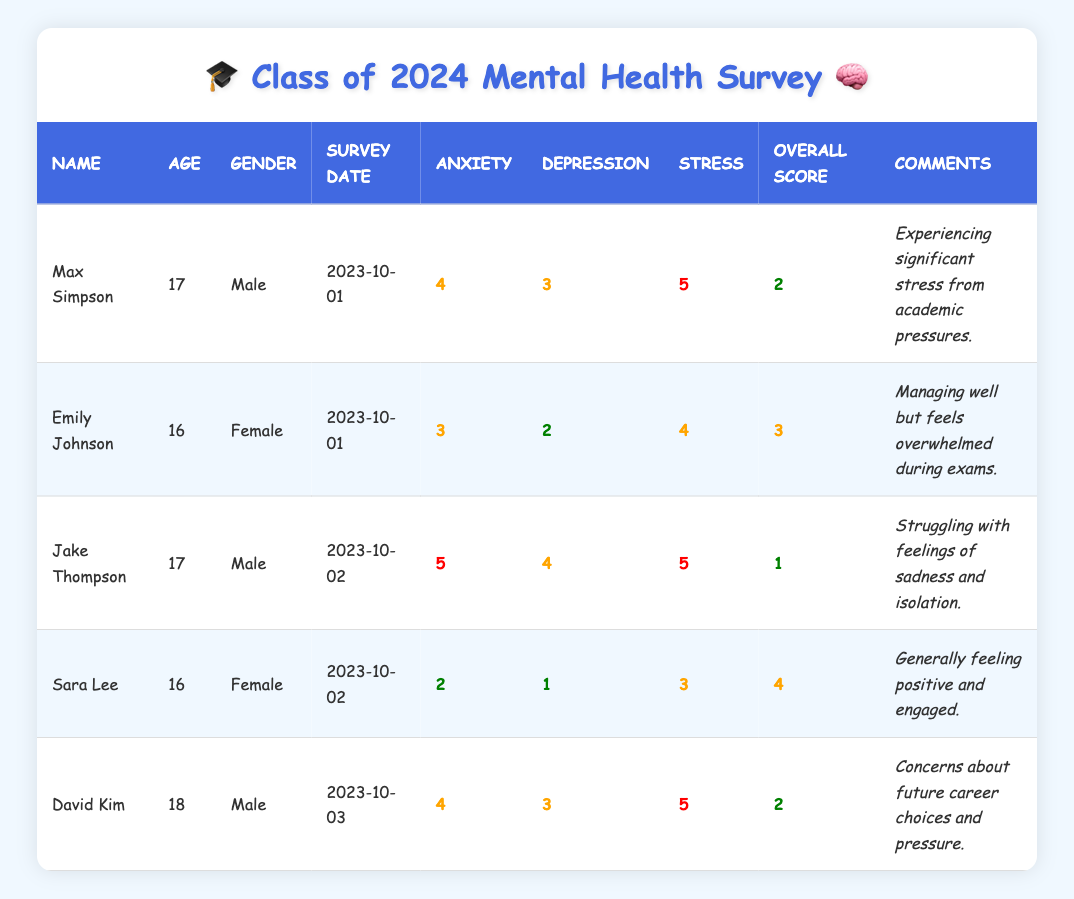What's the anxiety level reported by Max Simpson? The table shows that Max Simpson's anxiety level is listed under the "Anxiety" column, which has a value of 4.
Answer: 4 What is the overall mental health score of Sara Lee? In the table, we can find Sara Lee's overall mental health score in the "Overall Score" column, which is marked as 4.
Answer: 4 Who reported the highest stress level among the students? By looking at the "Stress" column, we can see that Jake Thompson has a stress level of 5, which is the highest compared to others.
Answer: Jake Thompson Is Emily Johnson's depression level higher than that of Max Simpson? We compare the depression levels in the "Depression" column: Emily Johnson has 2 and Max Simpson has 3. Since 2 is not greater than 3, the statement is false.
Answer: No What is the average anxiety level of all students surveyed? To find the average anxiety level, we add the anxiety levels: (4 + 3 + 5 + 2 + 4) = 18, and divide by 5 (the number of students). Thus, the average anxiety level is 18/5 = 3.6.
Answer: 3.6 How many students reported an overall mental health score of 2 or lower? Checking the "Overall Score" column, only Max Simpson and Jake Thompson reported scores of 2 or lower (Max with 2 and Jake with 1). Therefore, there are 2 students with such scores.
Answer: 2 Which student has the least concern about their mental health and how do we know? Sara Lee, who reported an overall mental health score of 4 and commented about feeling positive and engaged, has the least concern about her mental health. This is evident in her high score and positive comment.
Answer: Sara Lee What can we infer about the relationship between stress levels and overall mental health scores based on the table? By observing the data, there appears to be a trend where higher stress levels correlate with lower overall scores; for example, Jake Thompson has the highest stress level of 5 and the lowest overall score of 1, suggesting a negative relationship.
Answer: Higher stress levels correlate with lower overall scores Is there a student who feels overwhelmed during exams? Emily Johnson mentions feeling overwhelmed during exams in her comments, indicating she experiences stress related to exam times.
Answer: Yes, Emily Johnson 